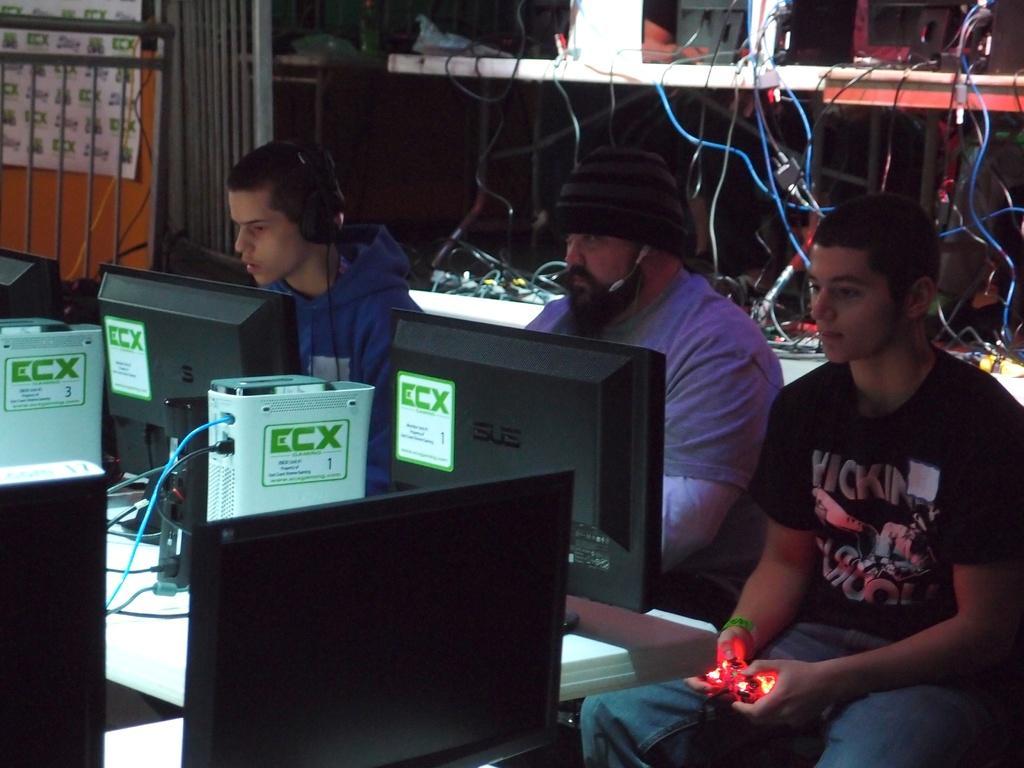Please provide a concise description of this image. In this image there are three people sitting on their chairs, in front of them there are monitors and other objects on the table and two are wearing the headset on their head and one is holding an object, behind them there are few objects connected with cables are placed on the shelves. On the left side of the image there is a railing. 